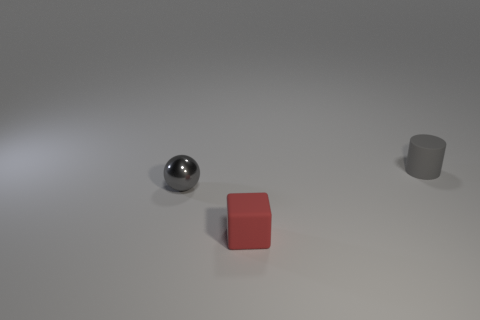Add 2 cylinders. How many objects exist? 5 Subtract 1 blocks. How many blocks are left? 0 Subtract all purple blocks. How many purple cylinders are left? 0 Subtract all matte cylinders. Subtract all small blue metallic cylinders. How many objects are left? 2 Add 3 gray cylinders. How many gray cylinders are left? 4 Add 3 small gray objects. How many small gray objects exist? 5 Subtract 0 yellow cylinders. How many objects are left? 3 Subtract all cylinders. How many objects are left? 2 